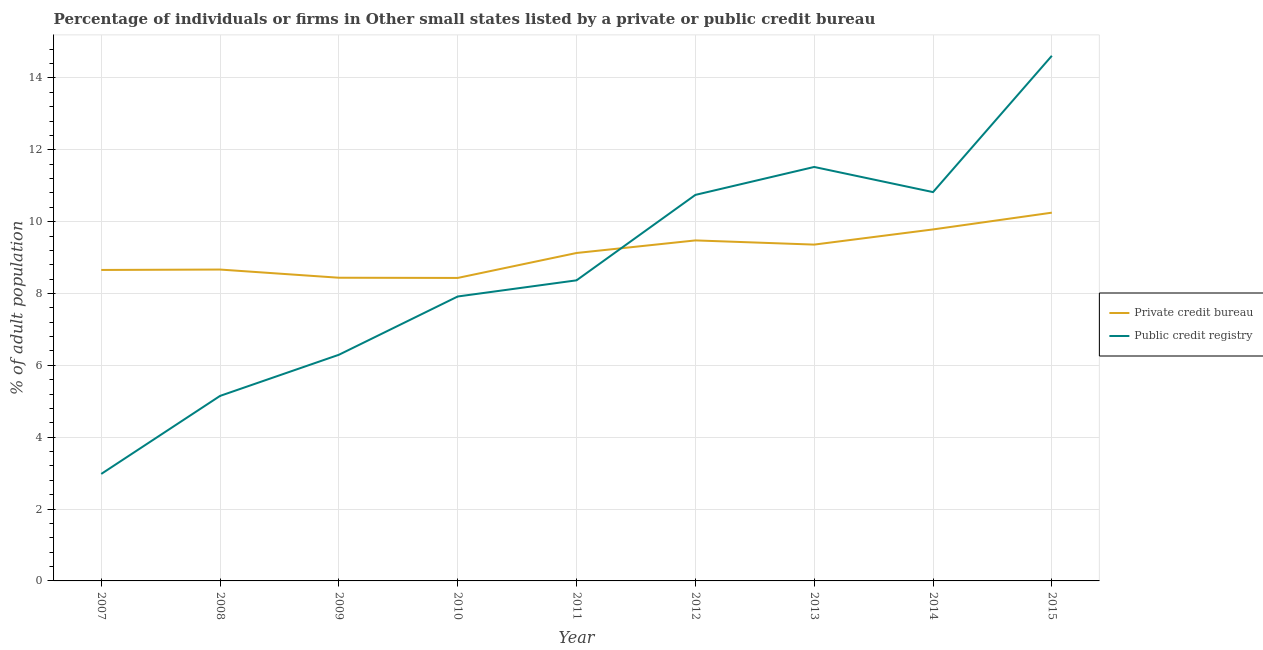Is the number of lines equal to the number of legend labels?
Offer a very short reply. Yes. What is the percentage of firms listed by private credit bureau in 2011?
Your answer should be very brief. 9.13. Across all years, what is the maximum percentage of firms listed by public credit bureau?
Give a very brief answer. 14.62. Across all years, what is the minimum percentage of firms listed by public credit bureau?
Your response must be concise. 2.98. In which year was the percentage of firms listed by public credit bureau maximum?
Offer a terse response. 2015. In which year was the percentage of firms listed by private credit bureau minimum?
Your answer should be compact. 2010. What is the total percentage of firms listed by private credit bureau in the graph?
Keep it short and to the point. 82.19. What is the difference between the percentage of firms listed by private credit bureau in 2007 and that in 2011?
Provide a succinct answer. -0.47. What is the difference between the percentage of firms listed by public credit bureau in 2008 and the percentage of firms listed by private credit bureau in 2010?
Offer a terse response. -3.28. What is the average percentage of firms listed by private credit bureau per year?
Your answer should be very brief. 9.13. In the year 2007, what is the difference between the percentage of firms listed by private credit bureau and percentage of firms listed by public credit bureau?
Your answer should be compact. 5.68. What is the ratio of the percentage of firms listed by private credit bureau in 2010 to that in 2014?
Offer a terse response. 0.86. Is the percentage of firms listed by public credit bureau in 2009 less than that in 2015?
Keep it short and to the point. Yes. What is the difference between the highest and the second highest percentage of firms listed by private credit bureau?
Keep it short and to the point. 0.47. What is the difference between the highest and the lowest percentage of firms listed by public credit bureau?
Your response must be concise. 11.64. Is the percentage of firms listed by private credit bureau strictly greater than the percentage of firms listed by public credit bureau over the years?
Your response must be concise. No. What is the difference between two consecutive major ticks on the Y-axis?
Provide a short and direct response. 2. Are the values on the major ticks of Y-axis written in scientific E-notation?
Provide a succinct answer. No. Does the graph contain any zero values?
Make the answer very short. No. Does the graph contain grids?
Your answer should be compact. Yes. How many legend labels are there?
Your response must be concise. 2. What is the title of the graph?
Make the answer very short. Percentage of individuals or firms in Other small states listed by a private or public credit bureau. What is the label or title of the Y-axis?
Give a very brief answer. % of adult population. What is the % of adult population of Private credit bureau in 2007?
Provide a succinct answer. 8.66. What is the % of adult population in Public credit registry in 2007?
Ensure brevity in your answer.  2.98. What is the % of adult population of Private credit bureau in 2008?
Offer a terse response. 8.67. What is the % of adult population in Public credit registry in 2008?
Keep it short and to the point. 5.15. What is the % of adult population in Private credit bureau in 2009?
Make the answer very short. 8.44. What is the % of adult population in Public credit registry in 2009?
Your answer should be compact. 6.29. What is the % of adult population in Private credit bureau in 2010?
Offer a terse response. 8.43. What is the % of adult population in Public credit registry in 2010?
Make the answer very short. 7.92. What is the % of adult population of Private credit bureau in 2011?
Make the answer very short. 9.13. What is the % of adult population of Public credit registry in 2011?
Ensure brevity in your answer.  8.37. What is the % of adult population of Private credit bureau in 2012?
Provide a succinct answer. 9.48. What is the % of adult population of Public credit registry in 2012?
Offer a very short reply. 10.74. What is the % of adult population of Private credit bureau in 2013?
Make the answer very short. 9.36. What is the % of adult population of Public credit registry in 2013?
Ensure brevity in your answer.  11.52. What is the % of adult population in Private credit bureau in 2014?
Give a very brief answer. 9.78. What is the % of adult population in Public credit registry in 2014?
Ensure brevity in your answer.  10.82. What is the % of adult population in Private credit bureau in 2015?
Give a very brief answer. 10.25. What is the % of adult population in Public credit registry in 2015?
Give a very brief answer. 14.62. Across all years, what is the maximum % of adult population in Private credit bureau?
Keep it short and to the point. 10.25. Across all years, what is the maximum % of adult population of Public credit registry?
Provide a succinct answer. 14.62. Across all years, what is the minimum % of adult population of Private credit bureau?
Ensure brevity in your answer.  8.43. Across all years, what is the minimum % of adult population in Public credit registry?
Offer a very short reply. 2.98. What is the total % of adult population in Private credit bureau in the graph?
Offer a terse response. 82.19. What is the total % of adult population in Public credit registry in the graph?
Offer a terse response. 78.41. What is the difference between the % of adult population in Private credit bureau in 2007 and that in 2008?
Your response must be concise. -0.01. What is the difference between the % of adult population of Public credit registry in 2007 and that in 2008?
Provide a succinct answer. -2.17. What is the difference between the % of adult population of Private credit bureau in 2007 and that in 2009?
Your response must be concise. 0.22. What is the difference between the % of adult population in Public credit registry in 2007 and that in 2009?
Your answer should be compact. -3.32. What is the difference between the % of adult population of Private credit bureau in 2007 and that in 2010?
Your response must be concise. 0.22. What is the difference between the % of adult population in Public credit registry in 2007 and that in 2010?
Ensure brevity in your answer.  -4.94. What is the difference between the % of adult population in Private credit bureau in 2007 and that in 2011?
Your answer should be very brief. -0.47. What is the difference between the % of adult population in Public credit registry in 2007 and that in 2011?
Offer a terse response. -5.39. What is the difference between the % of adult population of Private credit bureau in 2007 and that in 2012?
Your response must be concise. -0.82. What is the difference between the % of adult population in Public credit registry in 2007 and that in 2012?
Keep it short and to the point. -7.77. What is the difference between the % of adult population in Private credit bureau in 2007 and that in 2013?
Your answer should be compact. -0.71. What is the difference between the % of adult population in Public credit registry in 2007 and that in 2013?
Give a very brief answer. -8.54. What is the difference between the % of adult population of Private credit bureau in 2007 and that in 2014?
Provide a succinct answer. -1.13. What is the difference between the % of adult population in Public credit registry in 2007 and that in 2014?
Give a very brief answer. -7.84. What is the difference between the % of adult population in Private credit bureau in 2007 and that in 2015?
Your answer should be compact. -1.59. What is the difference between the % of adult population of Public credit registry in 2007 and that in 2015?
Provide a short and direct response. -11.64. What is the difference between the % of adult population of Private credit bureau in 2008 and that in 2009?
Keep it short and to the point. 0.23. What is the difference between the % of adult population in Public credit registry in 2008 and that in 2009?
Give a very brief answer. -1.14. What is the difference between the % of adult population in Private credit bureau in 2008 and that in 2010?
Your answer should be compact. 0.23. What is the difference between the % of adult population in Public credit registry in 2008 and that in 2010?
Provide a succinct answer. -2.77. What is the difference between the % of adult population in Private credit bureau in 2008 and that in 2011?
Offer a very short reply. -0.46. What is the difference between the % of adult population in Public credit registry in 2008 and that in 2011?
Give a very brief answer. -3.22. What is the difference between the % of adult population of Private credit bureau in 2008 and that in 2012?
Keep it short and to the point. -0.81. What is the difference between the % of adult population in Public credit registry in 2008 and that in 2012?
Provide a short and direct response. -5.59. What is the difference between the % of adult population in Private credit bureau in 2008 and that in 2013?
Your response must be concise. -0.69. What is the difference between the % of adult population in Public credit registry in 2008 and that in 2013?
Provide a succinct answer. -6.37. What is the difference between the % of adult population in Private credit bureau in 2008 and that in 2014?
Your answer should be compact. -1.12. What is the difference between the % of adult population of Public credit registry in 2008 and that in 2014?
Provide a short and direct response. -5.67. What is the difference between the % of adult population of Private credit bureau in 2008 and that in 2015?
Your answer should be very brief. -1.58. What is the difference between the % of adult population of Public credit registry in 2008 and that in 2015?
Your answer should be very brief. -9.47. What is the difference between the % of adult population of Private credit bureau in 2009 and that in 2010?
Provide a short and direct response. 0.01. What is the difference between the % of adult population of Public credit registry in 2009 and that in 2010?
Provide a short and direct response. -1.62. What is the difference between the % of adult population in Private credit bureau in 2009 and that in 2011?
Offer a terse response. -0.69. What is the difference between the % of adult population in Public credit registry in 2009 and that in 2011?
Make the answer very short. -2.07. What is the difference between the % of adult population in Private credit bureau in 2009 and that in 2012?
Give a very brief answer. -1.04. What is the difference between the % of adult population of Public credit registry in 2009 and that in 2012?
Your answer should be compact. -4.45. What is the difference between the % of adult population of Private credit bureau in 2009 and that in 2013?
Make the answer very short. -0.92. What is the difference between the % of adult population of Public credit registry in 2009 and that in 2013?
Offer a terse response. -5.23. What is the difference between the % of adult population in Private credit bureau in 2009 and that in 2014?
Offer a terse response. -1.34. What is the difference between the % of adult population of Public credit registry in 2009 and that in 2014?
Your answer should be compact. -4.53. What is the difference between the % of adult population in Private credit bureau in 2009 and that in 2015?
Provide a succinct answer. -1.81. What is the difference between the % of adult population of Public credit registry in 2009 and that in 2015?
Ensure brevity in your answer.  -8.32. What is the difference between the % of adult population in Private credit bureau in 2010 and that in 2011?
Give a very brief answer. -0.69. What is the difference between the % of adult population in Public credit registry in 2010 and that in 2011?
Make the answer very short. -0.45. What is the difference between the % of adult population of Private credit bureau in 2010 and that in 2012?
Make the answer very short. -1.04. What is the difference between the % of adult population in Public credit registry in 2010 and that in 2012?
Your response must be concise. -2.83. What is the difference between the % of adult population of Private credit bureau in 2010 and that in 2013?
Keep it short and to the point. -0.93. What is the difference between the % of adult population in Public credit registry in 2010 and that in 2013?
Offer a very short reply. -3.61. What is the difference between the % of adult population in Private credit bureau in 2010 and that in 2014?
Offer a very short reply. -1.35. What is the difference between the % of adult population of Public credit registry in 2010 and that in 2014?
Offer a very short reply. -2.91. What is the difference between the % of adult population in Private credit bureau in 2010 and that in 2015?
Provide a short and direct response. -1.82. What is the difference between the % of adult population of Private credit bureau in 2011 and that in 2012?
Offer a terse response. -0.35. What is the difference between the % of adult population in Public credit registry in 2011 and that in 2012?
Give a very brief answer. -2.38. What is the difference between the % of adult population in Private credit bureau in 2011 and that in 2013?
Offer a very short reply. -0.23. What is the difference between the % of adult population in Public credit registry in 2011 and that in 2013?
Give a very brief answer. -3.16. What is the difference between the % of adult population of Private credit bureau in 2011 and that in 2014?
Provide a succinct answer. -0.66. What is the difference between the % of adult population in Public credit registry in 2011 and that in 2014?
Make the answer very short. -2.46. What is the difference between the % of adult population in Private credit bureau in 2011 and that in 2015?
Make the answer very short. -1.12. What is the difference between the % of adult population of Public credit registry in 2011 and that in 2015?
Your response must be concise. -6.25. What is the difference between the % of adult population in Private credit bureau in 2012 and that in 2013?
Provide a succinct answer. 0.12. What is the difference between the % of adult population of Public credit registry in 2012 and that in 2013?
Provide a succinct answer. -0.78. What is the difference between the % of adult population of Private credit bureau in 2012 and that in 2014?
Ensure brevity in your answer.  -0.31. What is the difference between the % of adult population of Public credit registry in 2012 and that in 2014?
Offer a very short reply. -0.08. What is the difference between the % of adult population of Private credit bureau in 2012 and that in 2015?
Ensure brevity in your answer.  -0.77. What is the difference between the % of adult population in Public credit registry in 2012 and that in 2015?
Offer a terse response. -3.87. What is the difference between the % of adult population of Private credit bureau in 2013 and that in 2014?
Offer a terse response. -0.42. What is the difference between the % of adult population in Private credit bureau in 2013 and that in 2015?
Provide a succinct answer. -0.89. What is the difference between the % of adult population in Public credit registry in 2013 and that in 2015?
Keep it short and to the point. -3.09. What is the difference between the % of adult population of Private credit bureau in 2014 and that in 2015?
Make the answer very short. -0.47. What is the difference between the % of adult population of Public credit registry in 2014 and that in 2015?
Your answer should be very brief. -3.79. What is the difference between the % of adult population in Private credit bureau in 2007 and the % of adult population in Public credit registry in 2008?
Your response must be concise. 3.51. What is the difference between the % of adult population in Private credit bureau in 2007 and the % of adult population in Public credit registry in 2009?
Offer a terse response. 2.36. What is the difference between the % of adult population in Private credit bureau in 2007 and the % of adult population in Public credit registry in 2010?
Your answer should be compact. 0.74. What is the difference between the % of adult population in Private credit bureau in 2007 and the % of adult population in Public credit registry in 2011?
Your response must be concise. 0.29. What is the difference between the % of adult population in Private credit bureau in 2007 and the % of adult population in Public credit registry in 2012?
Your answer should be compact. -2.09. What is the difference between the % of adult population of Private credit bureau in 2007 and the % of adult population of Public credit registry in 2013?
Ensure brevity in your answer.  -2.87. What is the difference between the % of adult population in Private credit bureau in 2007 and the % of adult population in Public credit registry in 2014?
Offer a terse response. -2.17. What is the difference between the % of adult population in Private credit bureau in 2007 and the % of adult population in Public credit registry in 2015?
Make the answer very short. -5.96. What is the difference between the % of adult population in Private credit bureau in 2008 and the % of adult population in Public credit registry in 2009?
Make the answer very short. 2.37. What is the difference between the % of adult population of Private credit bureau in 2008 and the % of adult population of Public credit registry in 2010?
Your answer should be very brief. 0.75. What is the difference between the % of adult population in Private credit bureau in 2008 and the % of adult population in Public credit registry in 2011?
Your answer should be compact. 0.3. What is the difference between the % of adult population in Private credit bureau in 2008 and the % of adult population in Public credit registry in 2012?
Ensure brevity in your answer.  -2.08. What is the difference between the % of adult population in Private credit bureau in 2008 and the % of adult population in Public credit registry in 2013?
Offer a terse response. -2.86. What is the difference between the % of adult population of Private credit bureau in 2008 and the % of adult population of Public credit registry in 2014?
Make the answer very short. -2.16. What is the difference between the % of adult population of Private credit bureau in 2008 and the % of adult population of Public credit registry in 2015?
Provide a succinct answer. -5.95. What is the difference between the % of adult population of Private credit bureau in 2009 and the % of adult population of Public credit registry in 2010?
Ensure brevity in your answer.  0.52. What is the difference between the % of adult population in Private credit bureau in 2009 and the % of adult population in Public credit registry in 2011?
Ensure brevity in your answer.  0.07. What is the difference between the % of adult population of Private credit bureau in 2009 and the % of adult population of Public credit registry in 2012?
Your answer should be compact. -2.31. What is the difference between the % of adult population in Private credit bureau in 2009 and the % of adult population in Public credit registry in 2013?
Offer a very short reply. -3.08. What is the difference between the % of adult population of Private credit bureau in 2009 and the % of adult population of Public credit registry in 2014?
Your response must be concise. -2.38. What is the difference between the % of adult population in Private credit bureau in 2009 and the % of adult population in Public credit registry in 2015?
Provide a succinct answer. -6.18. What is the difference between the % of adult population in Private credit bureau in 2010 and the % of adult population in Public credit registry in 2011?
Provide a short and direct response. 0.07. What is the difference between the % of adult population in Private credit bureau in 2010 and the % of adult population in Public credit registry in 2012?
Provide a succinct answer. -2.31. What is the difference between the % of adult population in Private credit bureau in 2010 and the % of adult population in Public credit registry in 2013?
Give a very brief answer. -3.09. What is the difference between the % of adult population in Private credit bureau in 2010 and the % of adult population in Public credit registry in 2014?
Make the answer very short. -2.39. What is the difference between the % of adult population in Private credit bureau in 2010 and the % of adult population in Public credit registry in 2015?
Your response must be concise. -6.18. What is the difference between the % of adult population in Private credit bureau in 2011 and the % of adult population in Public credit registry in 2012?
Provide a short and direct response. -1.62. What is the difference between the % of adult population of Private credit bureau in 2011 and the % of adult population of Public credit registry in 2013?
Your response must be concise. -2.39. What is the difference between the % of adult population in Private credit bureau in 2011 and the % of adult population in Public credit registry in 2014?
Your answer should be very brief. -1.69. What is the difference between the % of adult population in Private credit bureau in 2011 and the % of adult population in Public credit registry in 2015?
Your response must be concise. -5.49. What is the difference between the % of adult population of Private credit bureau in 2012 and the % of adult population of Public credit registry in 2013?
Offer a very short reply. -2.04. What is the difference between the % of adult population in Private credit bureau in 2012 and the % of adult population in Public credit registry in 2014?
Provide a succinct answer. -1.34. What is the difference between the % of adult population of Private credit bureau in 2012 and the % of adult population of Public credit registry in 2015?
Keep it short and to the point. -5.14. What is the difference between the % of adult population in Private credit bureau in 2013 and the % of adult population in Public credit registry in 2014?
Make the answer very short. -1.46. What is the difference between the % of adult population of Private credit bureau in 2013 and the % of adult population of Public credit registry in 2015?
Provide a short and direct response. -5.26. What is the difference between the % of adult population in Private credit bureau in 2014 and the % of adult population in Public credit registry in 2015?
Your response must be concise. -4.83. What is the average % of adult population in Private credit bureau per year?
Keep it short and to the point. 9.13. What is the average % of adult population of Public credit registry per year?
Your answer should be compact. 8.71. In the year 2007, what is the difference between the % of adult population of Private credit bureau and % of adult population of Public credit registry?
Provide a short and direct response. 5.68. In the year 2008, what is the difference between the % of adult population in Private credit bureau and % of adult population in Public credit registry?
Your answer should be compact. 3.52. In the year 2009, what is the difference between the % of adult population in Private credit bureau and % of adult population in Public credit registry?
Offer a terse response. 2.14. In the year 2010, what is the difference between the % of adult population of Private credit bureau and % of adult population of Public credit registry?
Ensure brevity in your answer.  0.52. In the year 2011, what is the difference between the % of adult population in Private credit bureau and % of adult population in Public credit registry?
Offer a terse response. 0.76. In the year 2012, what is the difference between the % of adult population of Private credit bureau and % of adult population of Public credit registry?
Provide a succinct answer. -1.27. In the year 2013, what is the difference between the % of adult population of Private credit bureau and % of adult population of Public credit registry?
Give a very brief answer. -2.16. In the year 2014, what is the difference between the % of adult population in Private credit bureau and % of adult population in Public credit registry?
Your answer should be compact. -1.04. In the year 2015, what is the difference between the % of adult population of Private credit bureau and % of adult population of Public credit registry?
Your answer should be very brief. -4.37. What is the ratio of the % of adult population of Private credit bureau in 2007 to that in 2008?
Keep it short and to the point. 1. What is the ratio of the % of adult population in Public credit registry in 2007 to that in 2008?
Provide a succinct answer. 0.58. What is the ratio of the % of adult population of Private credit bureau in 2007 to that in 2009?
Make the answer very short. 1.03. What is the ratio of the % of adult population in Public credit registry in 2007 to that in 2009?
Your answer should be compact. 0.47. What is the ratio of the % of adult population in Private credit bureau in 2007 to that in 2010?
Ensure brevity in your answer.  1.03. What is the ratio of the % of adult population of Public credit registry in 2007 to that in 2010?
Your answer should be compact. 0.38. What is the ratio of the % of adult population of Private credit bureau in 2007 to that in 2011?
Ensure brevity in your answer.  0.95. What is the ratio of the % of adult population of Public credit registry in 2007 to that in 2011?
Make the answer very short. 0.36. What is the ratio of the % of adult population in Private credit bureau in 2007 to that in 2012?
Make the answer very short. 0.91. What is the ratio of the % of adult population of Public credit registry in 2007 to that in 2012?
Your answer should be very brief. 0.28. What is the ratio of the % of adult population in Private credit bureau in 2007 to that in 2013?
Make the answer very short. 0.92. What is the ratio of the % of adult population in Public credit registry in 2007 to that in 2013?
Offer a terse response. 0.26. What is the ratio of the % of adult population in Private credit bureau in 2007 to that in 2014?
Your response must be concise. 0.88. What is the ratio of the % of adult population of Public credit registry in 2007 to that in 2014?
Offer a terse response. 0.28. What is the ratio of the % of adult population in Private credit bureau in 2007 to that in 2015?
Keep it short and to the point. 0.84. What is the ratio of the % of adult population in Public credit registry in 2007 to that in 2015?
Offer a very short reply. 0.2. What is the ratio of the % of adult population in Private credit bureau in 2008 to that in 2009?
Your response must be concise. 1.03. What is the ratio of the % of adult population in Public credit registry in 2008 to that in 2009?
Give a very brief answer. 0.82. What is the ratio of the % of adult population of Private credit bureau in 2008 to that in 2010?
Give a very brief answer. 1.03. What is the ratio of the % of adult population in Public credit registry in 2008 to that in 2010?
Offer a terse response. 0.65. What is the ratio of the % of adult population of Private credit bureau in 2008 to that in 2011?
Your answer should be very brief. 0.95. What is the ratio of the % of adult population of Public credit registry in 2008 to that in 2011?
Ensure brevity in your answer.  0.62. What is the ratio of the % of adult population in Private credit bureau in 2008 to that in 2012?
Provide a short and direct response. 0.91. What is the ratio of the % of adult population in Public credit registry in 2008 to that in 2012?
Your answer should be very brief. 0.48. What is the ratio of the % of adult population of Private credit bureau in 2008 to that in 2013?
Ensure brevity in your answer.  0.93. What is the ratio of the % of adult population in Public credit registry in 2008 to that in 2013?
Offer a terse response. 0.45. What is the ratio of the % of adult population in Private credit bureau in 2008 to that in 2014?
Offer a terse response. 0.89. What is the ratio of the % of adult population of Public credit registry in 2008 to that in 2014?
Offer a very short reply. 0.48. What is the ratio of the % of adult population of Private credit bureau in 2008 to that in 2015?
Ensure brevity in your answer.  0.85. What is the ratio of the % of adult population of Public credit registry in 2008 to that in 2015?
Provide a short and direct response. 0.35. What is the ratio of the % of adult population in Public credit registry in 2009 to that in 2010?
Provide a short and direct response. 0.8. What is the ratio of the % of adult population of Private credit bureau in 2009 to that in 2011?
Provide a succinct answer. 0.92. What is the ratio of the % of adult population in Public credit registry in 2009 to that in 2011?
Offer a terse response. 0.75. What is the ratio of the % of adult population in Private credit bureau in 2009 to that in 2012?
Your answer should be very brief. 0.89. What is the ratio of the % of adult population of Public credit registry in 2009 to that in 2012?
Keep it short and to the point. 0.59. What is the ratio of the % of adult population of Private credit bureau in 2009 to that in 2013?
Keep it short and to the point. 0.9. What is the ratio of the % of adult population of Public credit registry in 2009 to that in 2013?
Offer a very short reply. 0.55. What is the ratio of the % of adult population in Private credit bureau in 2009 to that in 2014?
Your answer should be very brief. 0.86. What is the ratio of the % of adult population in Public credit registry in 2009 to that in 2014?
Your answer should be very brief. 0.58. What is the ratio of the % of adult population of Private credit bureau in 2009 to that in 2015?
Make the answer very short. 0.82. What is the ratio of the % of adult population in Public credit registry in 2009 to that in 2015?
Provide a short and direct response. 0.43. What is the ratio of the % of adult population in Private credit bureau in 2010 to that in 2011?
Your answer should be very brief. 0.92. What is the ratio of the % of adult population in Public credit registry in 2010 to that in 2011?
Your answer should be very brief. 0.95. What is the ratio of the % of adult population in Private credit bureau in 2010 to that in 2012?
Your answer should be compact. 0.89. What is the ratio of the % of adult population of Public credit registry in 2010 to that in 2012?
Your answer should be very brief. 0.74. What is the ratio of the % of adult population in Private credit bureau in 2010 to that in 2013?
Provide a short and direct response. 0.9. What is the ratio of the % of adult population of Public credit registry in 2010 to that in 2013?
Offer a terse response. 0.69. What is the ratio of the % of adult population in Private credit bureau in 2010 to that in 2014?
Provide a succinct answer. 0.86. What is the ratio of the % of adult population of Public credit registry in 2010 to that in 2014?
Make the answer very short. 0.73. What is the ratio of the % of adult population of Private credit bureau in 2010 to that in 2015?
Provide a succinct answer. 0.82. What is the ratio of the % of adult population of Public credit registry in 2010 to that in 2015?
Your answer should be very brief. 0.54. What is the ratio of the % of adult population in Private credit bureau in 2011 to that in 2012?
Offer a terse response. 0.96. What is the ratio of the % of adult population of Public credit registry in 2011 to that in 2012?
Your response must be concise. 0.78. What is the ratio of the % of adult population in Private credit bureau in 2011 to that in 2013?
Provide a short and direct response. 0.98. What is the ratio of the % of adult population of Public credit registry in 2011 to that in 2013?
Your answer should be very brief. 0.73. What is the ratio of the % of adult population of Private credit bureau in 2011 to that in 2014?
Provide a succinct answer. 0.93. What is the ratio of the % of adult population of Public credit registry in 2011 to that in 2014?
Make the answer very short. 0.77. What is the ratio of the % of adult population in Private credit bureau in 2011 to that in 2015?
Provide a short and direct response. 0.89. What is the ratio of the % of adult population in Public credit registry in 2011 to that in 2015?
Offer a very short reply. 0.57. What is the ratio of the % of adult population of Private credit bureau in 2012 to that in 2013?
Make the answer very short. 1.01. What is the ratio of the % of adult population in Public credit registry in 2012 to that in 2013?
Provide a short and direct response. 0.93. What is the ratio of the % of adult population of Private credit bureau in 2012 to that in 2014?
Offer a very short reply. 0.97. What is the ratio of the % of adult population in Public credit registry in 2012 to that in 2014?
Give a very brief answer. 0.99. What is the ratio of the % of adult population of Private credit bureau in 2012 to that in 2015?
Provide a short and direct response. 0.92. What is the ratio of the % of adult population in Public credit registry in 2012 to that in 2015?
Provide a short and direct response. 0.74. What is the ratio of the % of adult population in Private credit bureau in 2013 to that in 2014?
Keep it short and to the point. 0.96. What is the ratio of the % of adult population in Public credit registry in 2013 to that in 2014?
Provide a succinct answer. 1.06. What is the ratio of the % of adult population of Private credit bureau in 2013 to that in 2015?
Ensure brevity in your answer.  0.91. What is the ratio of the % of adult population in Public credit registry in 2013 to that in 2015?
Offer a very short reply. 0.79. What is the ratio of the % of adult population in Private credit bureau in 2014 to that in 2015?
Provide a short and direct response. 0.95. What is the ratio of the % of adult population of Public credit registry in 2014 to that in 2015?
Keep it short and to the point. 0.74. What is the difference between the highest and the second highest % of adult population of Private credit bureau?
Your response must be concise. 0.47. What is the difference between the highest and the second highest % of adult population in Public credit registry?
Ensure brevity in your answer.  3.09. What is the difference between the highest and the lowest % of adult population of Private credit bureau?
Provide a succinct answer. 1.82. What is the difference between the highest and the lowest % of adult population of Public credit registry?
Keep it short and to the point. 11.64. 